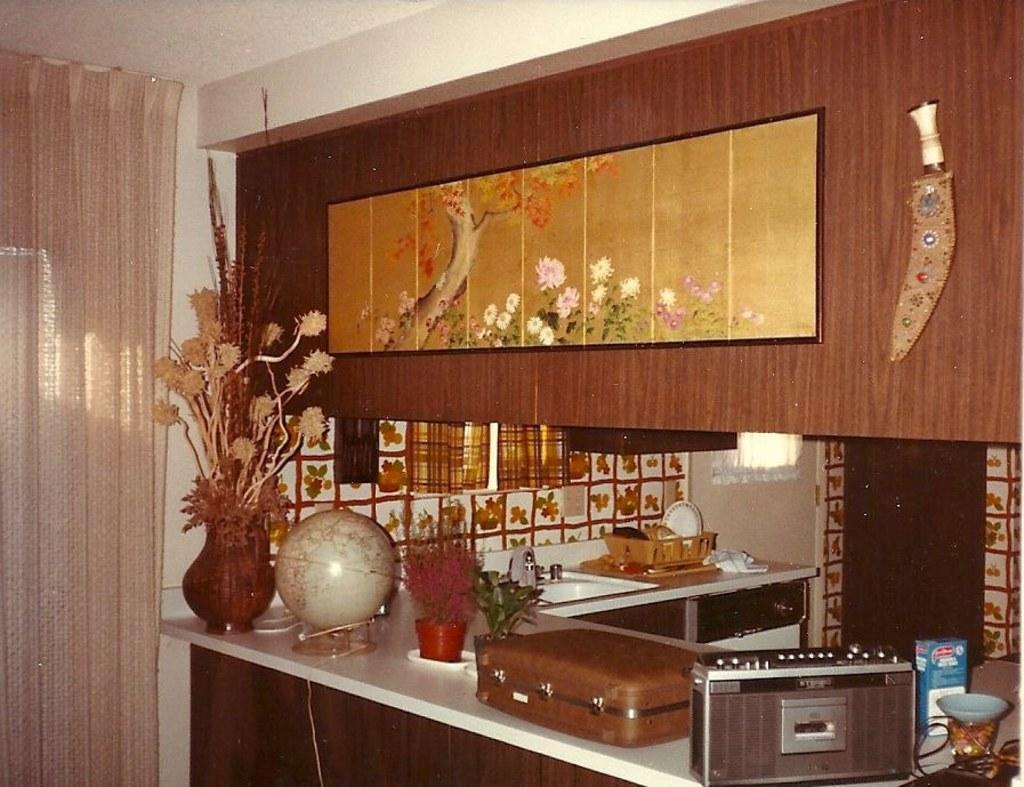In one or two sentences, can you explain what this image depicts? In this image I can see the suitcase, flower vase, globe and few objects on the white color surface. In the background I can see the sink and few plates on the counter top and I can also see few curtain. In front I can see the wooden object. 